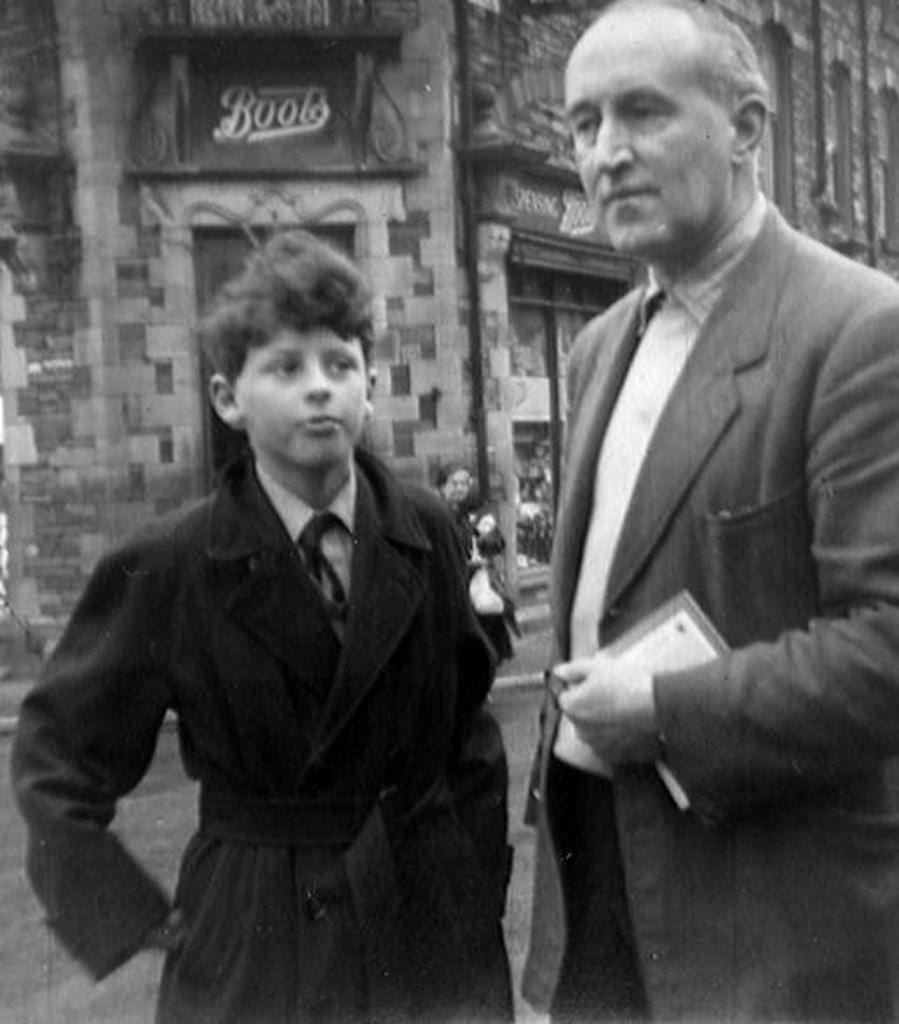Please provide a concise description of this image. In this image we can see two people standing. In the background there is a building and we can see a person. There is a board. The man standing on the right is holding a book. 